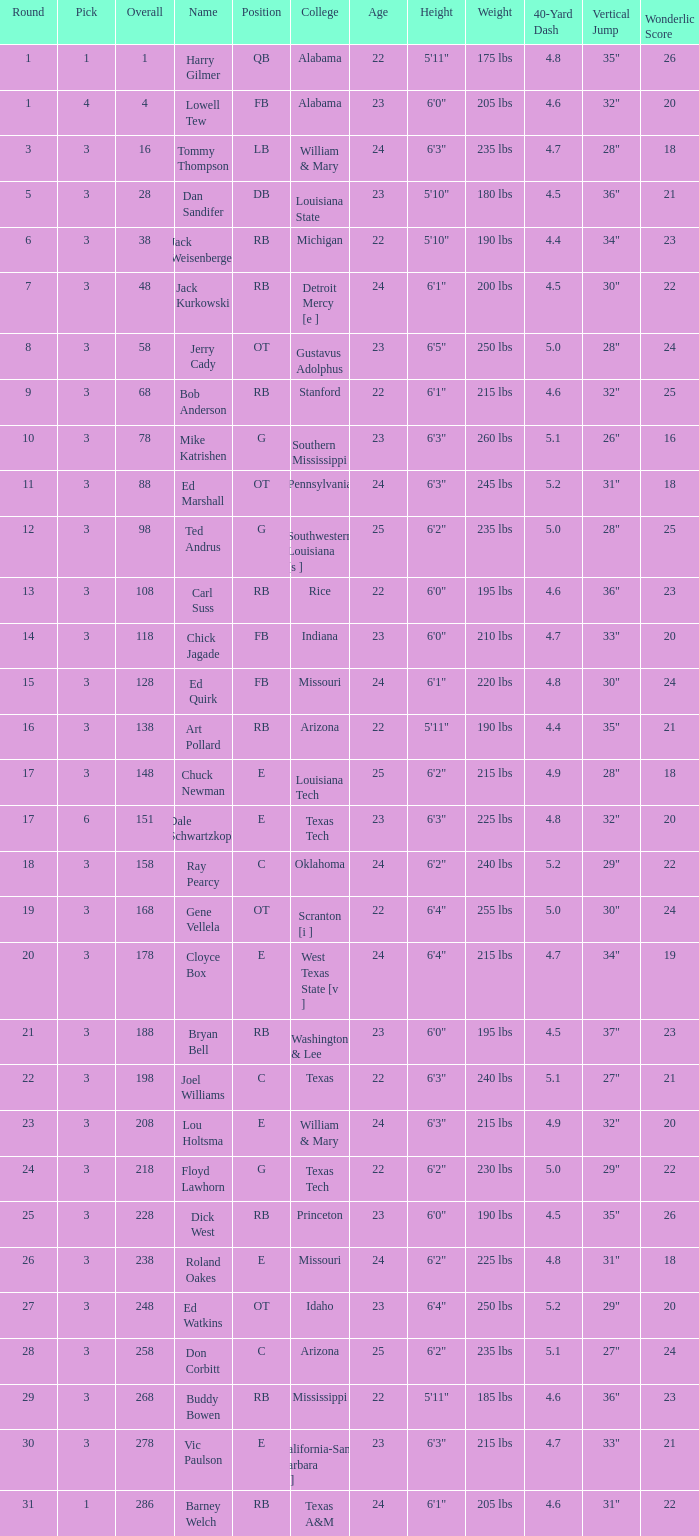What is stanford's average overall? 68.0. 